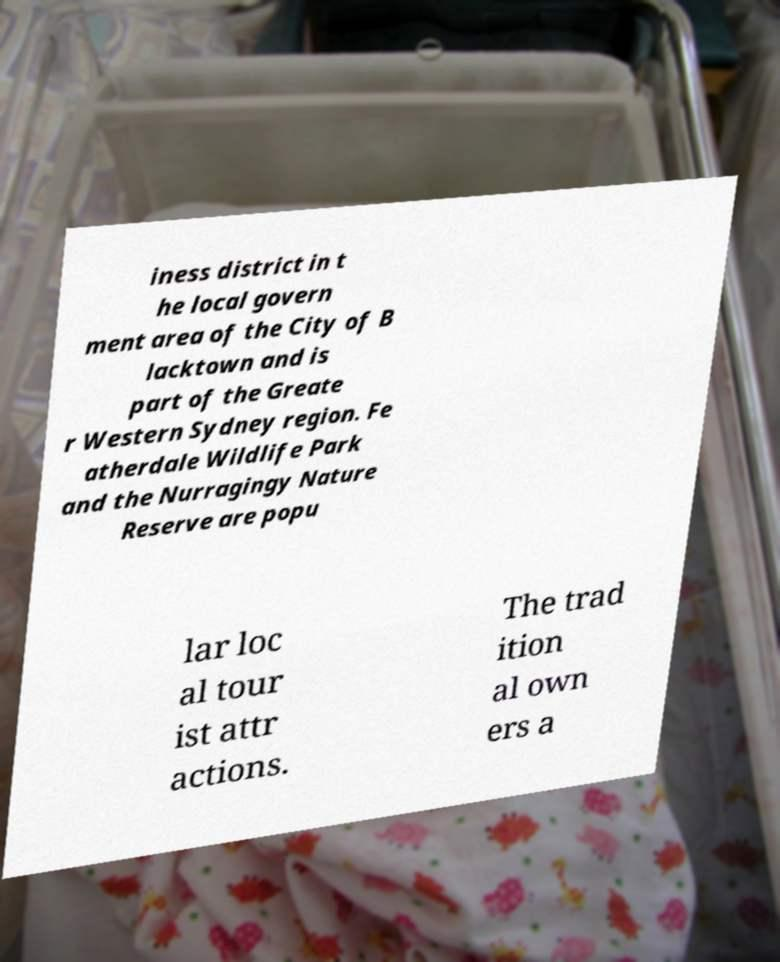Please read and relay the text visible in this image. What does it say? iness district in t he local govern ment area of the City of B lacktown and is part of the Greate r Western Sydney region. Fe atherdale Wildlife Park and the Nurragingy Nature Reserve are popu lar loc al tour ist attr actions. The trad ition al own ers a 